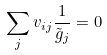<formula> <loc_0><loc_0><loc_500><loc_500>\sum _ { j } v _ { i j } \frac { 1 } { \tilde { g } _ { j } } = 0</formula> 